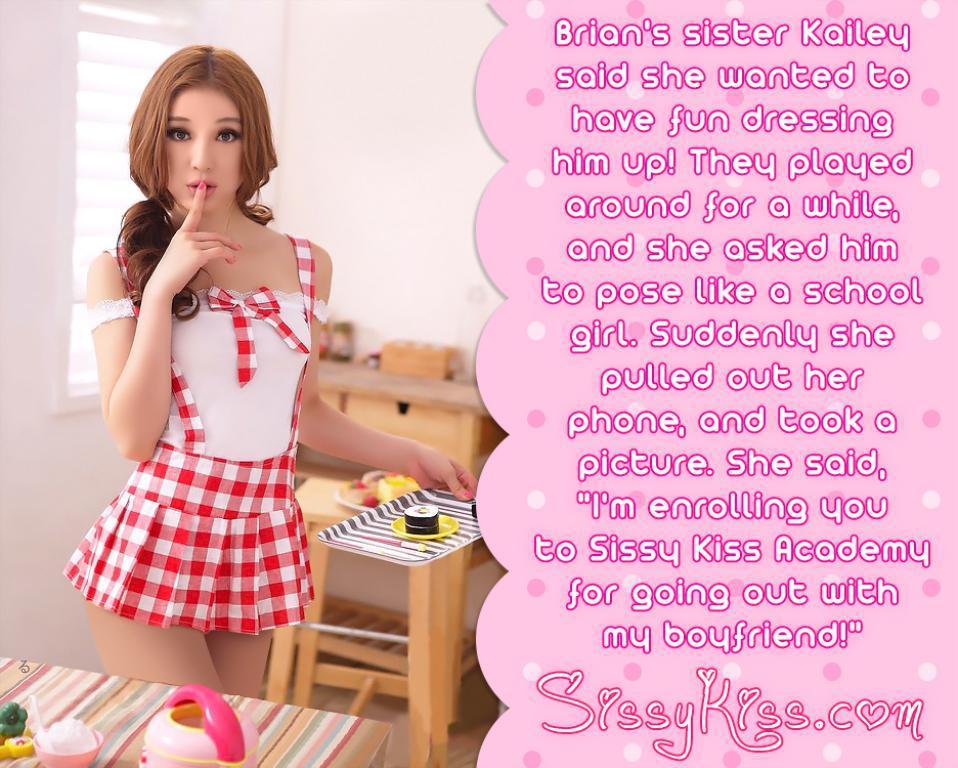In one or two sentences, can you explain what this image depicts? In this image there is a picture of a woman holding the tray in her hand, inside the woman there is some text, in front of the woman there are some objects on the table, behind the woman there is a wooden stool and a table, on the table there are some objects, in the background of the image there is a window on the wall. 